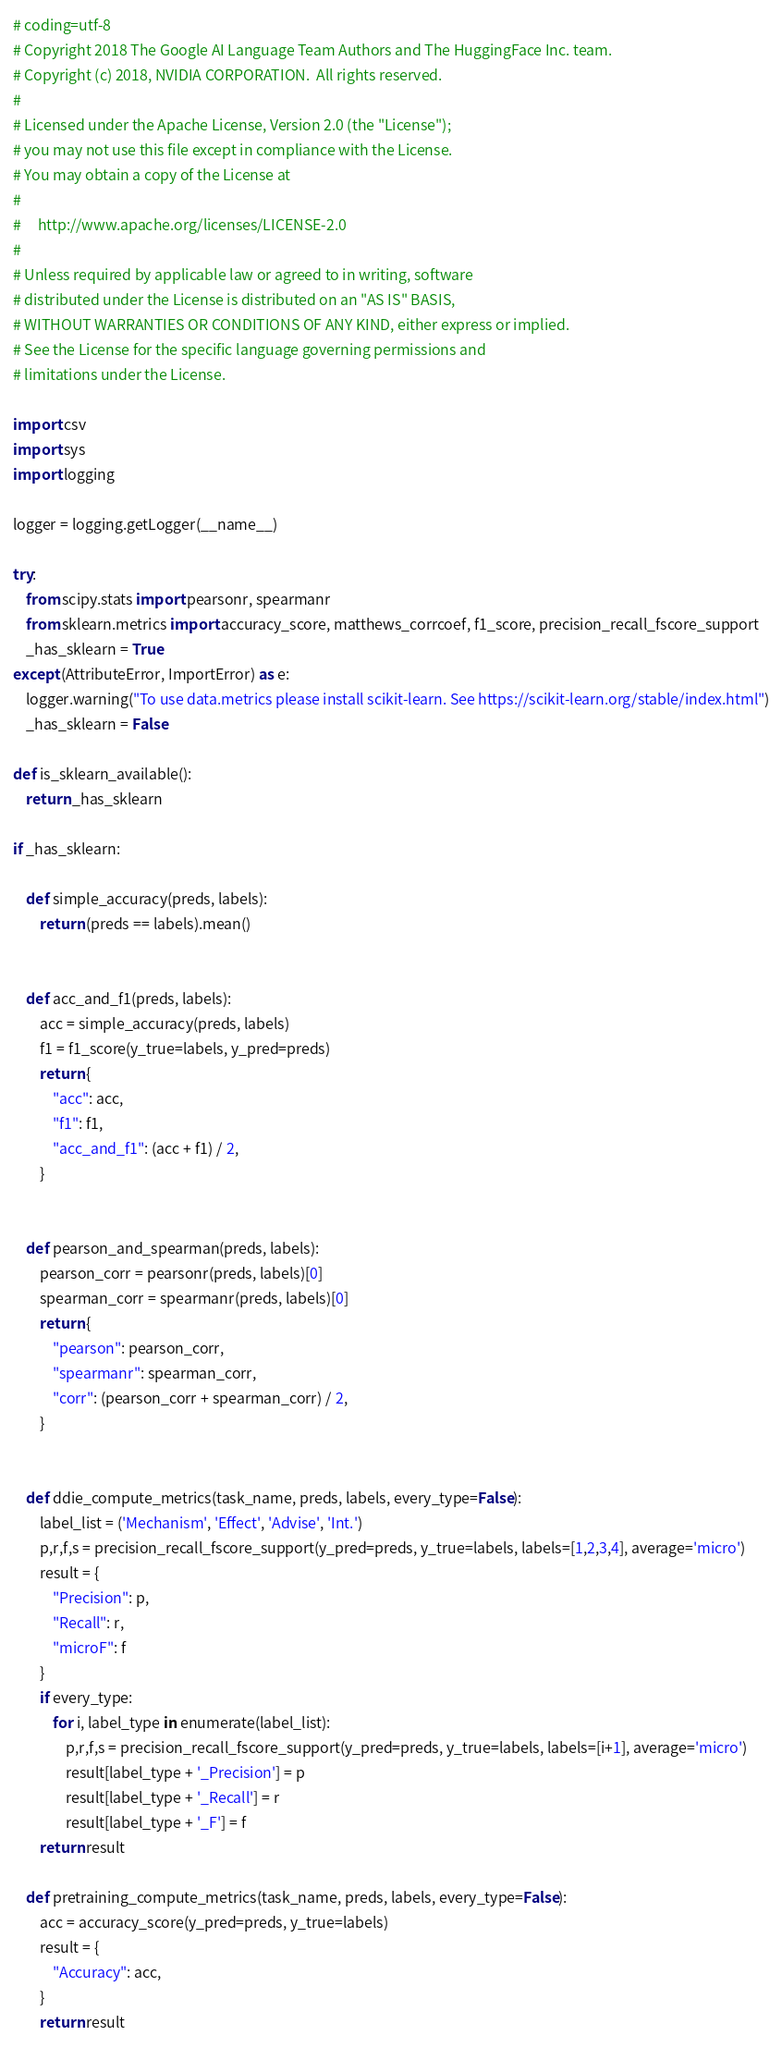<code> <loc_0><loc_0><loc_500><loc_500><_Python_># coding=utf-8
# Copyright 2018 The Google AI Language Team Authors and The HuggingFace Inc. team.
# Copyright (c) 2018, NVIDIA CORPORATION.  All rights reserved.
#
# Licensed under the Apache License, Version 2.0 (the "License");
# you may not use this file except in compliance with the License.
# You may obtain a copy of the License at
#
#     http://www.apache.org/licenses/LICENSE-2.0
#
# Unless required by applicable law or agreed to in writing, software
# distributed under the License is distributed on an "AS IS" BASIS,
# WITHOUT WARRANTIES OR CONDITIONS OF ANY KIND, either express or implied.
# See the License for the specific language governing permissions and
# limitations under the License.

import csv
import sys
import logging

logger = logging.getLogger(__name__)

try:
    from scipy.stats import pearsonr, spearmanr
    from sklearn.metrics import accuracy_score, matthews_corrcoef, f1_score, precision_recall_fscore_support
    _has_sklearn = True
except (AttributeError, ImportError) as e:
    logger.warning("To use data.metrics please install scikit-learn. See https://scikit-learn.org/stable/index.html")
    _has_sklearn = False

def is_sklearn_available():
    return _has_sklearn

if _has_sklearn:

    def simple_accuracy(preds, labels):
        return (preds == labels).mean()


    def acc_and_f1(preds, labels):
        acc = simple_accuracy(preds, labels)
        f1 = f1_score(y_true=labels, y_pred=preds)
        return {
            "acc": acc,
            "f1": f1,
            "acc_and_f1": (acc + f1) / 2,
        }


    def pearson_and_spearman(preds, labels):
        pearson_corr = pearsonr(preds, labels)[0]
        spearman_corr = spearmanr(preds, labels)[0]
        return {
            "pearson": pearson_corr,
            "spearmanr": spearman_corr,
            "corr": (pearson_corr + spearman_corr) / 2,
        }


    def ddie_compute_metrics(task_name, preds, labels, every_type=False):
        label_list = ('Mechanism', 'Effect', 'Advise', 'Int.')
        p,r,f,s = precision_recall_fscore_support(y_pred=preds, y_true=labels, labels=[1,2,3,4], average='micro')
        result = {
            "Precision": p,
            "Recall": r,
            "microF": f
        }
        if every_type:
            for i, label_type in enumerate(label_list):
                p,r,f,s = precision_recall_fscore_support(y_pred=preds, y_true=labels, labels=[i+1], average='micro')
                result[label_type + '_Precision'] = p
                result[label_type + '_Recall'] = r
                result[label_type + '_F'] = f
        return result

    def pretraining_compute_metrics(task_name, preds, labels, every_type=False):
        acc = accuracy_score(y_pred=preds, y_true=labels)
        result = {
            "Accuracy": acc,
        }
        return result
</code> 